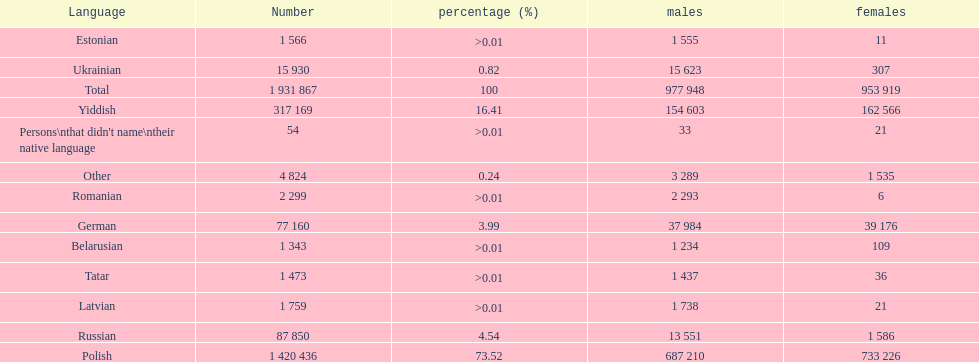Which language had the smallest number of females speaking it. Romanian. Parse the full table. {'header': ['Language', 'Number', 'percentage (%)', 'males', 'females'], 'rows': [['Estonian', '1 566', '>0.01', '1 555', '11'], ['Ukrainian', '15 930', '0.82', '15 623', '307'], ['Total', '1 931 867', '100', '977 948', '953 919'], ['Yiddish', '317 169', '16.41', '154 603', '162 566'], ["Persons\\nthat didn't name\\ntheir native language", '54', '>0.01', '33', '21'], ['Other', '4 824', '0.24', '3 289', '1 535'], ['Romanian', '2 299', '>0.01', '2 293', '6'], ['German', '77 160', '3.99', '37 984', '39 176'], ['Belarusian', '1 343', '>0.01', '1 234', '109'], ['Tatar', '1 473', '>0.01', '1 437', '36'], ['Latvian', '1 759', '>0.01', '1 738', '21'], ['Russian', '87 850', '4.54', '13 551', '1 586'], ['Polish', '1 420 436', '73.52', '687 210', '733 226']]} 